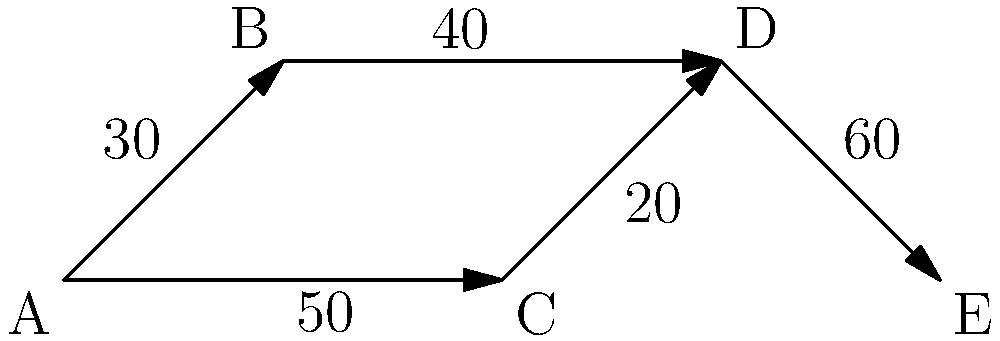The diagram represents passenger flow through different sections of an airport terminal. Vertices represent checkpoints, and edge weights indicate the number of passengers per hour. What is the maximum number of passengers that can pass through the terminal per hour, and which path should be prioritized for enhanced security measures? To solve this problem, we need to use the concept of maximum flow in a network:

1. Identify all possible paths from entry (A) to exit (E):
   Path 1: A → B → D → E
   Path 2: A → C → D → E

2. Calculate the flow for each path:
   Path 1: min(30, 40, 60) = 30 passengers/hour
   Path 2: min(50, 20, 60) = 20 passengers/hour

3. The maximum flow is the sum of these paths:
   Maximum flow = 30 + 20 = 50 passengers/hour

4. To determine which path to prioritize for security measures, we need to consider the path with the highest flow:
   Path 1 has a higher flow (30 passengers/hour) compared to Path 2 (20 passengers/hour).

Therefore, the maximum number of passengers that can pass through the terminal per hour is 50, and Path 1 (A → B → D → E) should be prioritized for enhanced security measures due to its higher passenger flow.
Answer: 50 passengers/hour; prioritize path A → B → D → E 